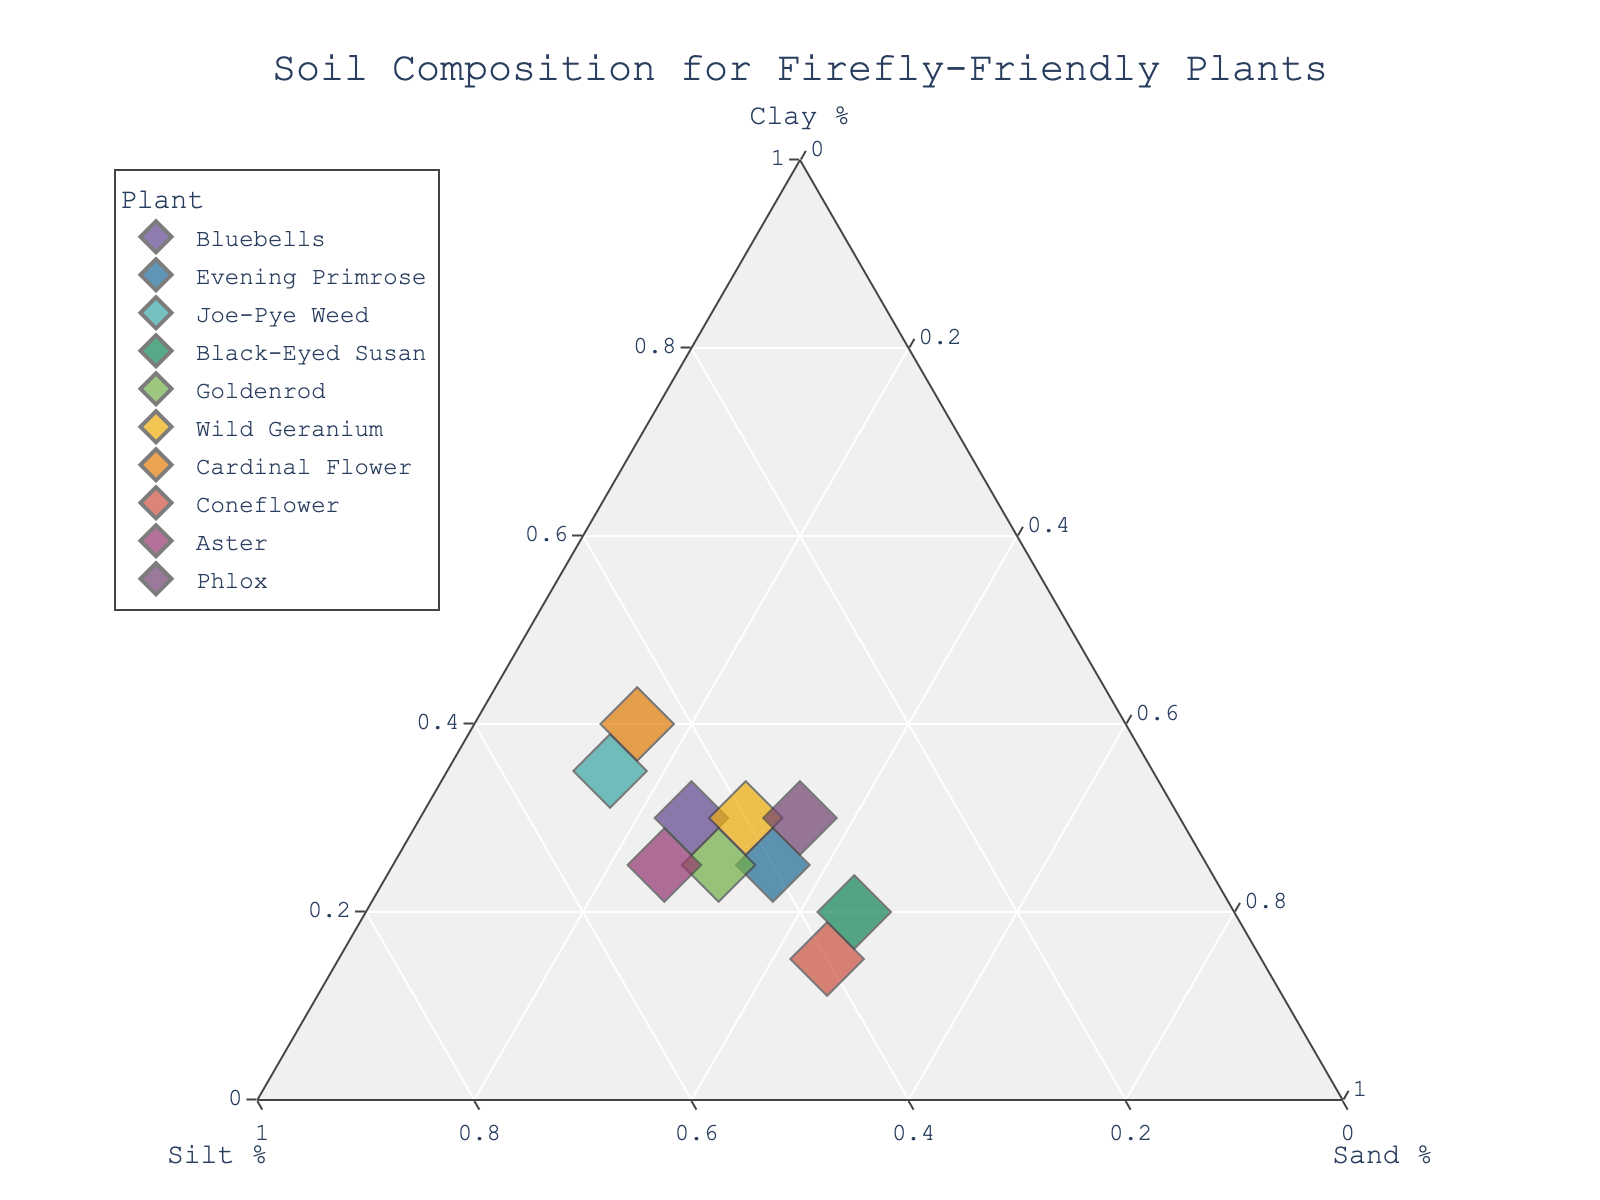What's the title of the figure? The title is usually placed at the top of the figure and helps to understand the main topic or objective of the visual representation.
Answer: Soil Composition for Firefly-Friendly Plants How many plants are represented in the plot? Each point represents a plant, and the legend on the right side lists all the plant names. Count the number of plant names to find the answer.
Answer: 10 Which plant has the highest percentage of clay? Look for the point closest to the vertex labeled "Clay %" on the ternary plot. Cross-reference this with the hover text or legend.
Answer: Cardinal Flower What's the range of sand percentage values shown in the plot? Identify the smallest and largest sand percentage values among the data points by observing the axis labeled "Sand %" and the distribution of points along this axis.
Answer: 15% to 45% What is the average percentage of silt among all plants? Sum all the silt percentages from the data points and divide by the number of plants: (45+40+50+35+45+40+45+40+50+35)/10. The calculation is (425/10).
Answer: 42.5% Which plant has the most balanced composition of clay, silt, and sand? This plant will be closest to the center of the ternary plot, representing an equal proportion of all three components. Identify the point nearest to the center.
Answer: Phlox How does the clay percentage of Bluebells compare to that of Coneflower? Locate the points for Bluebells and Coneflower. Then use their positions in relation to the "Clay %" axis to compare their clay percentage. Bluebells is close to 30%, and Coneflower is close to 15%.
Answer: Bluebells > Coneflower Calculate the difference in silt percentage between Joe-Pye Weed and Aster. Identify the silt percentages for both plants from their positions on the "Silt %" axis. Joe-Pye Weed is at 50%, and Aster is also at 50%. Subtract Aster's silt percentage from Joe-Pye Weed's.
Answer: 0% Which plant has the lowest percentage of sand, and what is it? Find the point nearest to the vertex labeled "Sand %". The plant name will be associated with this point when hovering over it.
Answer: Cardinal Flower at 15% Is there any plant with an equal percentage of clay and sand? Look for points where the distances to the "Clay %" and "Sand %" axes are equal. The point should lie along the line bisecting the two axes.
Answer: None 